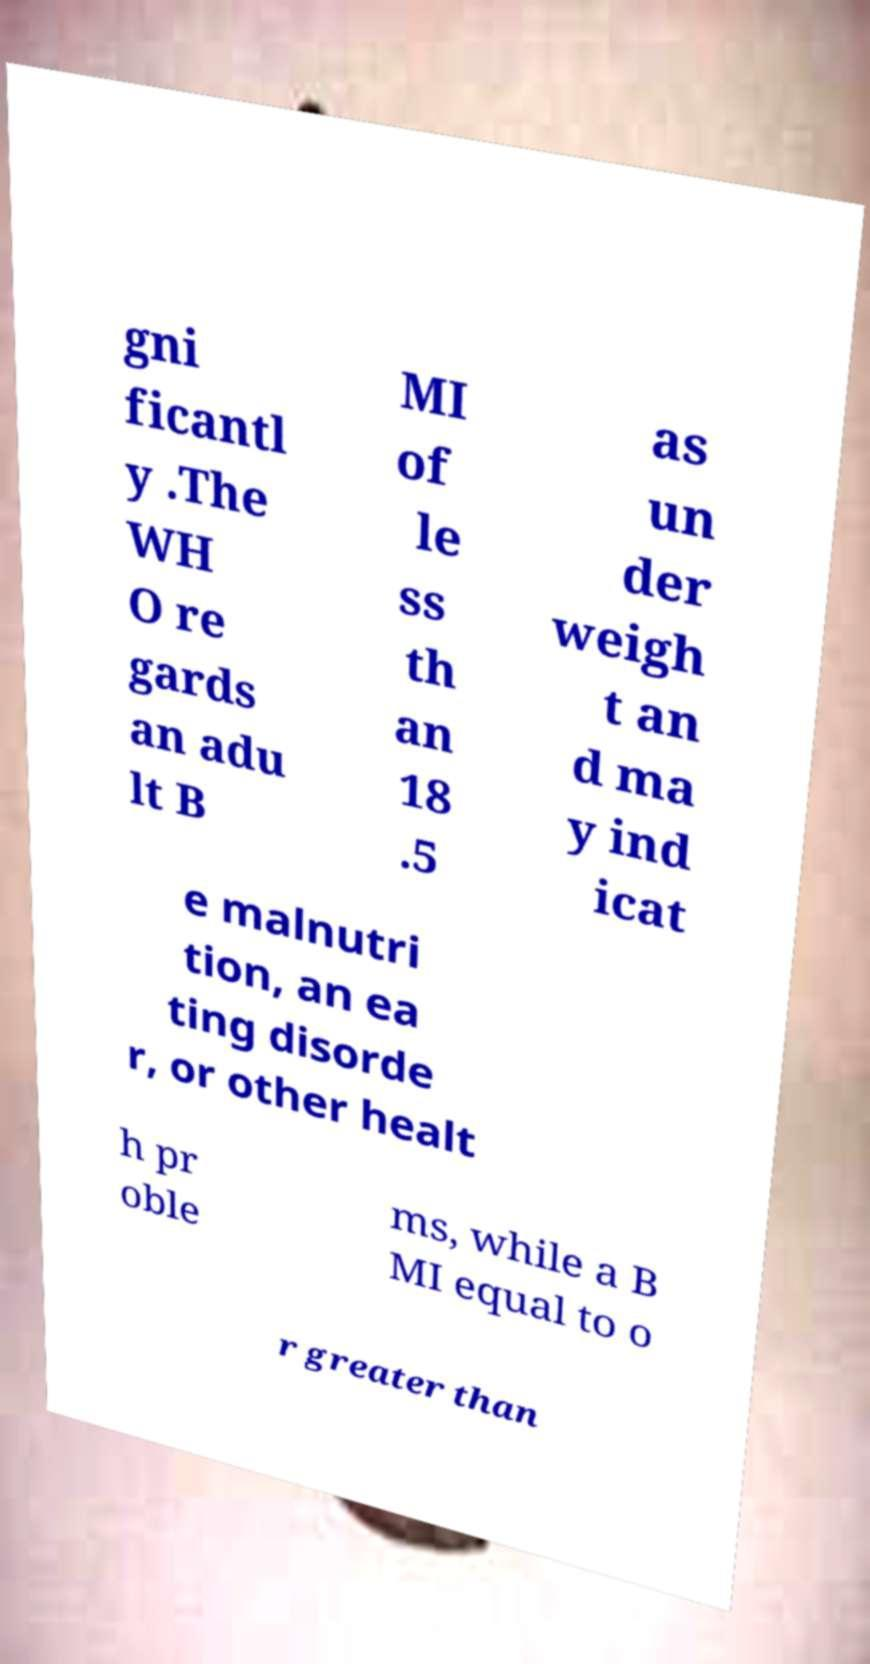Can you accurately transcribe the text from the provided image for me? gni ficantl y .The WH O re gards an adu lt B MI of le ss th an 18 .5 as un der weigh t an d ma y ind icat e malnutri tion, an ea ting disorde r, or other healt h pr oble ms, while a B MI equal to o r greater than 